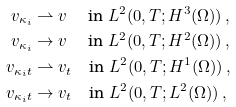<formula> <loc_0><loc_0><loc_500><loc_500>v _ { \kappa _ { i } } & \rightharpoonup v \quad \ \text {in } L ^ { 2 } ( 0 , T ; H ^ { 3 } ( \Omega ) ) \, , \\ v _ { \kappa _ { i } } & \to v \quad \ \text {in } L ^ { 2 } ( 0 , T ; H ^ { 2 } ( \Omega ) ) \, , \\ v _ { \kappa _ { i } t } & \rightharpoonup v _ { t } \quad \text {in } L ^ { 2 } ( 0 , T ; H ^ { 1 } ( \Omega ) ) \, , \\ v _ { \kappa _ { i } t } & \to v _ { t } \quad \text {in } L ^ { 2 } ( 0 , T ; L ^ { 2 } ( \Omega ) ) \, ,</formula> 